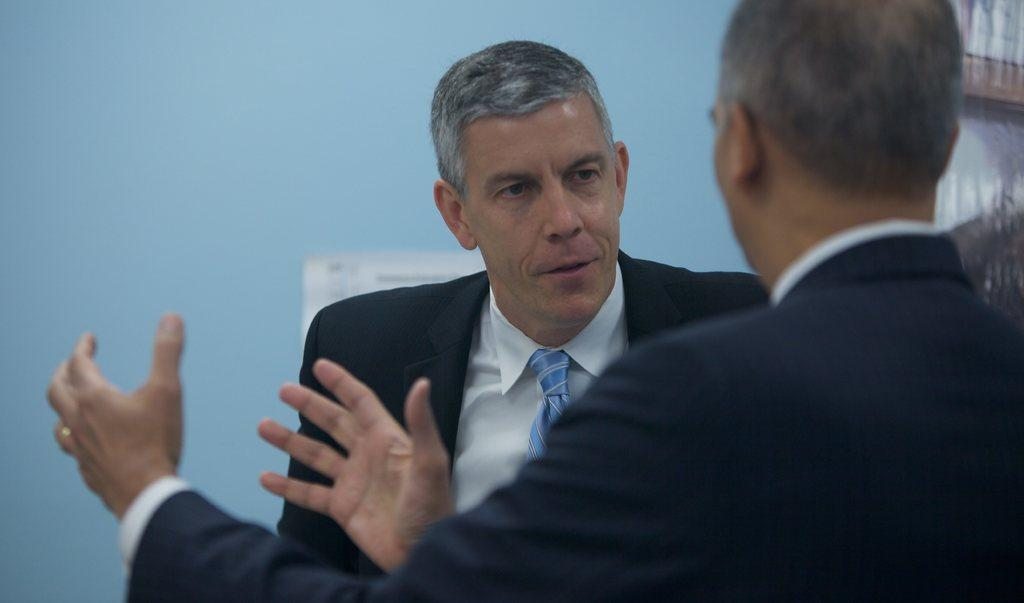How many people are present in the image? There are two people in the image. What can be seen in the background of the image? There is a wall in the background of the image. What type of news is being discussed by the two people in the image? There is no indication in the image that the two people are discussing news, so it cannot be determined from the picture. 